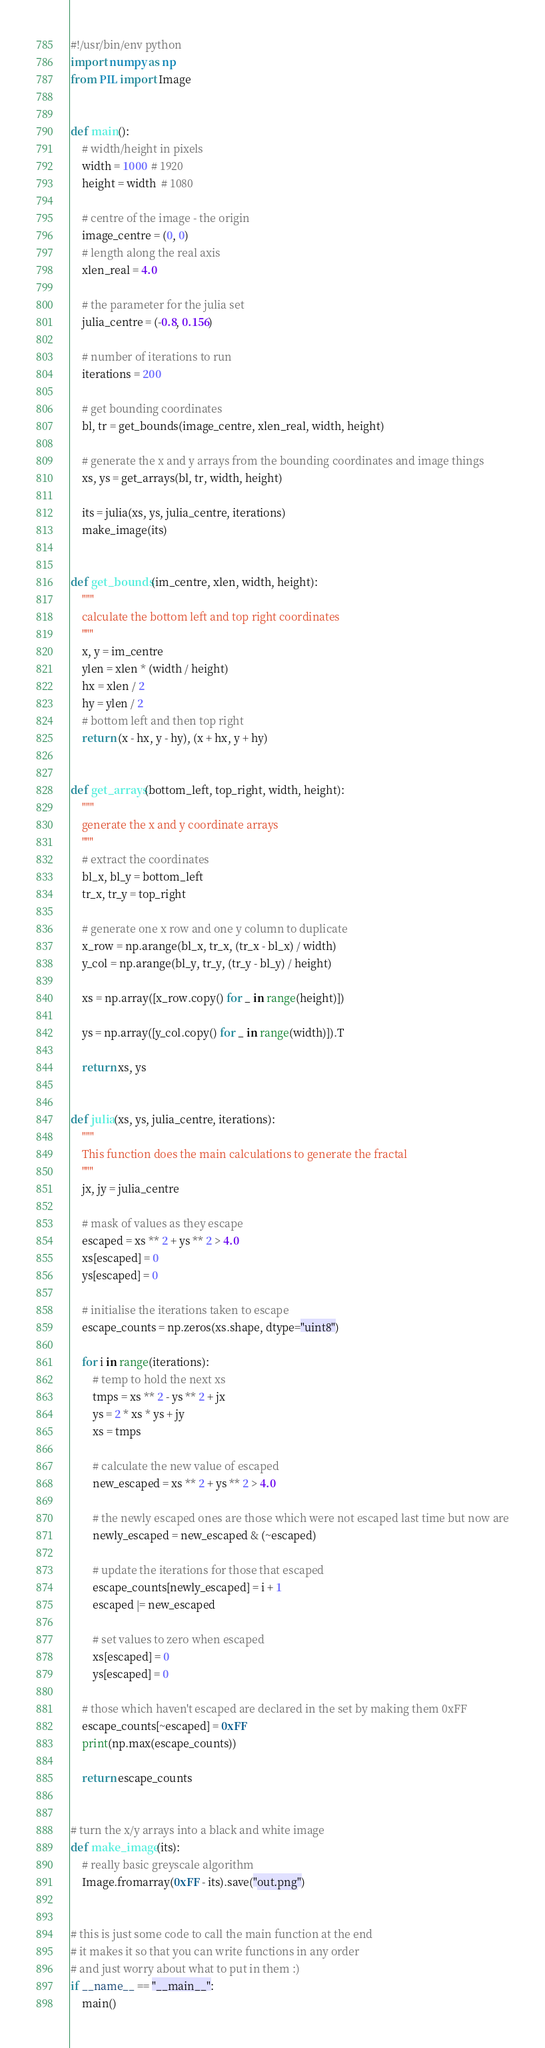<code> <loc_0><loc_0><loc_500><loc_500><_Python_>#!/usr/bin/env python
import numpy as np
from PIL import Image


def main():
    # width/height in pixels
    width = 1000  # 1920
    height = width  # 1080

    # centre of the image - the origin
    image_centre = (0, 0)
    # length along the real axis
    xlen_real = 4.0

    # the parameter for the julia set
    julia_centre = (-0.8, 0.156)

    # number of iterations to run
    iterations = 200

    # get bounding coordinates
    bl, tr = get_bounds(image_centre, xlen_real, width, height)

    # generate the x and y arrays from the bounding coordinates and image things
    xs, ys = get_arrays(bl, tr, width, height)

    its = julia(xs, ys, julia_centre, iterations)
    make_image(its)


def get_bounds(im_centre, xlen, width, height):
    """
    calculate the bottom left and top right coordinates
    """
    x, y = im_centre
    ylen = xlen * (width / height)
    hx = xlen / 2
    hy = ylen / 2
    # bottom left and then top right
    return (x - hx, y - hy), (x + hx, y + hy)


def get_arrays(bottom_left, top_right, width, height):
    """
    generate the x and y coordinate arrays
    """
    # extract the coordinates
    bl_x, bl_y = bottom_left
    tr_x, tr_y = top_right

    # generate one x row and one y column to duplicate
    x_row = np.arange(bl_x, tr_x, (tr_x - bl_x) / width)
    y_col = np.arange(bl_y, tr_y, (tr_y - bl_y) / height)

    xs = np.array([x_row.copy() for _ in range(height)])

    ys = np.array([y_col.copy() for _ in range(width)]).T

    return xs, ys


def julia(xs, ys, julia_centre, iterations):
    """
    This function does the main calculations to generate the fractal
    """
    jx, jy = julia_centre

    # mask of values as they escape
    escaped = xs ** 2 + ys ** 2 > 4.0
    xs[escaped] = 0
    ys[escaped] = 0

    # initialise the iterations taken to escape
    escape_counts = np.zeros(xs.shape, dtype="uint8")

    for i in range(iterations):
        # temp to hold the next xs
        tmps = xs ** 2 - ys ** 2 + jx
        ys = 2 * xs * ys + jy
        xs = tmps

        # calculate the new value of escaped
        new_escaped = xs ** 2 + ys ** 2 > 4.0

        # the newly escaped ones are those which were not escaped last time but now are
        newly_escaped = new_escaped & (~escaped)

        # update the iterations for those that escaped
        escape_counts[newly_escaped] = i + 1
        escaped |= new_escaped

        # set values to zero when escaped
        xs[escaped] = 0
        ys[escaped] = 0

    # those which haven't escaped are declared in the set by making them 0xFF
    escape_counts[~escaped] = 0xFF
    print(np.max(escape_counts))

    return escape_counts


# turn the x/y arrays into a black and white image
def make_image(its):
    # really basic greyscale algorithm
    Image.fromarray(0xFF - its).save("out.png")


# this is just some code to call the main function at the end
# it makes it so that you can write functions in any order
# and just worry about what to put in them :)
if __name__ == "__main__":
    main()
</code> 